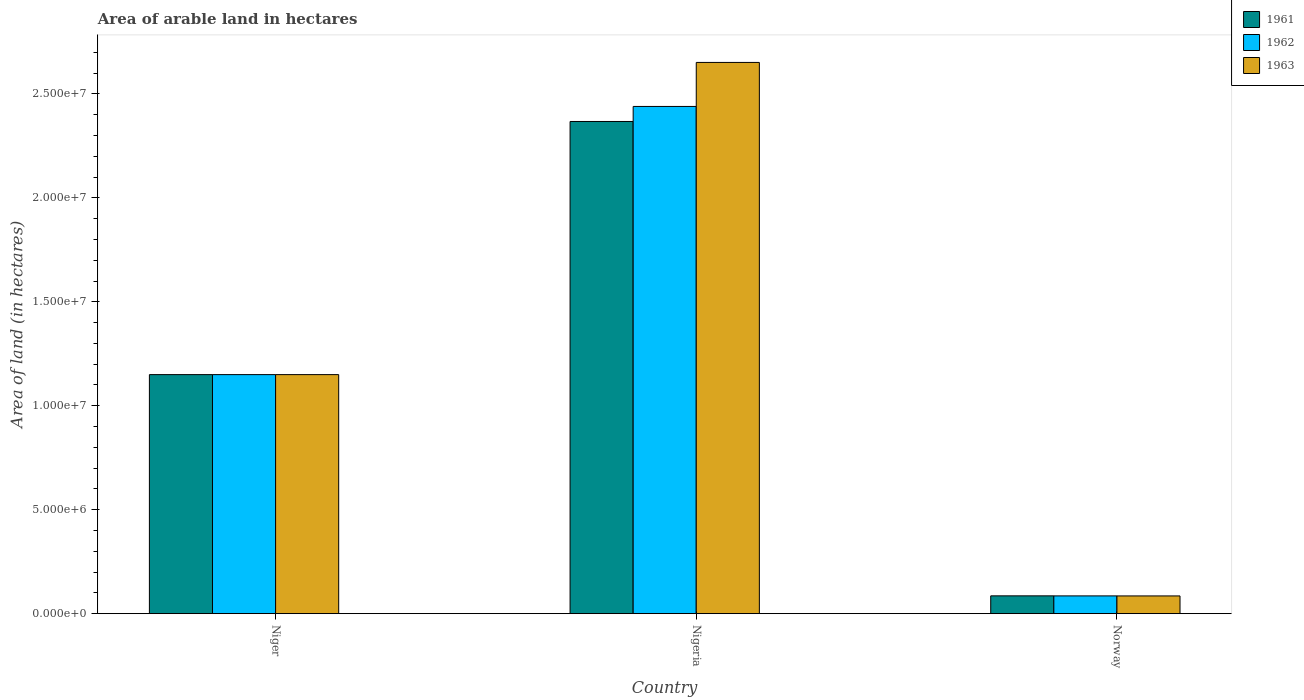How many groups of bars are there?
Give a very brief answer. 3. Are the number of bars per tick equal to the number of legend labels?
Provide a succinct answer. Yes. Are the number of bars on each tick of the X-axis equal?
Your answer should be very brief. Yes. How many bars are there on the 3rd tick from the left?
Give a very brief answer. 3. How many bars are there on the 2nd tick from the right?
Ensure brevity in your answer.  3. What is the label of the 1st group of bars from the left?
Offer a terse response. Niger. In how many cases, is the number of bars for a given country not equal to the number of legend labels?
Make the answer very short. 0. What is the total arable land in 1961 in Niger?
Your answer should be compact. 1.15e+07. Across all countries, what is the maximum total arable land in 1963?
Ensure brevity in your answer.  2.65e+07. Across all countries, what is the minimum total arable land in 1963?
Offer a very short reply. 8.52e+05. In which country was the total arable land in 1962 maximum?
Keep it short and to the point. Nigeria. In which country was the total arable land in 1962 minimum?
Ensure brevity in your answer.  Norway. What is the total total arable land in 1962 in the graph?
Provide a succinct answer. 3.68e+07. What is the difference between the total arable land in 1962 in Niger and that in Nigeria?
Provide a succinct answer. -1.29e+07. What is the difference between the total arable land in 1963 in Niger and the total arable land in 1962 in Norway?
Your answer should be compact. 1.06e+07. What is the average total arable land in 1962 per country?
Your answer should be compact. 1.23e+07. What is the difference between the total arable land of/in 1961 and total arable land of/in 1962 in Niger?
Your response must be concise. 0. What is the ratio of the total arable land in 1963 in Niger to that in Norway?
Provide a short and direct response. 13.5. Is the total arable land in 1962 in Nigeria less than that in Norway?
Your answer should be very brief. No. Is the difference between the total arable land in 1961 in Niger and Nigeria greater than the difference between the total arable land in 1962 in Niger and Nigeria?
Offer a very short reply. Yes. What is the difference between the highest and the second highest total arable land in 1962?
Ensure brevity in your answer.  2.35e+07. What is the difference between the highest and the lowest total arable land in 1961?
Provide a succinct answer. 2.28e+07. In how many countries, is the total arable land in 1962 greater than the average total arable land in 1962 taken over all countries?
Provide a succinct answer. 1. What does the 1st bar from the left in Niger represents?
Give a very brief answer. 1961. Are all the bars in the graph horizontal?
Your response must be concise. No. Where does the legend appear in the graph?
Give a very brief answer. Top right. How many legend labels are there?
Your answer should be compact. 3. How are the legend labels stacked?
Provide a short and direct response. Vertical. What is the title of the graph?
Offer a very short reply. Area of arable land in hectares. What is the label or title of the Y-axis?
Provide a succinct answer. Area of land (in hectares). What is the Area of land (in hectares) in 1961 in Niger?
Make the answer very short. 1.15e+07. What is the Area of land (in hectares) in 1962 in Niger?
Your response must be concise. 1.15e+07. What is the Area of land (in hectares) in 1963 in Niger?
Make the answer very short. 1.15e+07. What is the Area of land (in hectares) in 1961 in Nigeria?
Provide a succinct answer. 2.37e+07. What is the Area of land (in hectares) in 1962 in Nigeria?
Your answer should be very brief. 2.44e+07. What is the Area of land (in hectares) of 1963 in Nigeria?
Offer a very short reply. 2.65e+07. What is the Area of land (in hectares) of 1961 in Norway?
Keep it short and to the point. 8.56e+05. What is the Area of land (in hectares) of 1962 in Norway?
Ensure brevity in your answer.  8.54e+05. What is the Area of land (in hectares) of 1963 in Norway?
Ensure brevity in your answer.  8.52e+05. Across all countries, what is the maximum Area of land (in hectares) in 1961?
Give a very brief answer. 2.37e+07. Across all countries, what is the maximum Area of land (in hectares) in 1962?
Your response must be concise. 2.44e+07. Across all countries, what is the maximum Area of land (in hectares) in 1963?
Give a very brief answer. 2.65e+07. Across all countries, what is the minimum Area of land (in hectares) of 1961?
Provide a succinct answer. 8.56e+05. Across all countries, what is the minimum Area of land (in hectares) in 1962?
Offer a very short reply. 8.54e+05. Across all countries, what is the minimum Area of land (in hectares) of 1963?
Ensure brevity in your answer.  8.52e+05. What is the total Area of land (in hectares) in 1961 in the graph?
Provide a short and direct response. 3.60e+07. What is the total Area of land (in hectares) in 1962 in the graph?
Your response must be concise. 3.68e+07. What is the total Area of land (in hectares) of 1963 in the graph?
Your answer should be very brief. 3.89e+07. What is the difference between the Area of land (in hectares) of 1961 in Niger and that in Nigeria?
Offer a terse response. -1.22e+07. What is the difference between the Area of land (in hectares) in 1962 in Niger and that in Nigeria?
Offer a terse response. -1.29e+07. What is the difference between the Area of land (in hectares) in 1963 in Niger and that in Nigeria?
Your answer should be very brief. -1.50e+07. What is the difference between the Area of land (in hectares) in 1961 in Niger and that in Norway?
Offer a terse response. 1.06e+07. What is the difference between the Area of land (in hectares) of 1962 in Niger and that in Norway?
Ensure brevity in your answer.  1.06e+07. What is the difference between the Area of land (in hectares) in 1963 in Niger and that in Norway?
Give a very brief answer. 1.06e+07. What is the difference between the Area of land (in hectares) in 1961 in Nigeria and that in Norway?
Your response must be concise. 2.28e+07. What is the difference between the Area of land (in hectares) of 1962 in Nigeria and that in Norway?
Give a very brief answer. 2.35e+07. What is the difference between the Area of land (in hectares) of 1963 in Nigeria and that in Norway?
Provide a succinct answer. 2.57e+07. What is the difference between the Area of land (in hectares) of 1961 in Niger and the Area of land (in hectares) of 1962 in Nigeria?
Keep it short and to the point. -1.29e+07. What is the difference between the Area of land (in hectares) in 1961 in Niger and the Area of land (in hectares) in 1963 in Nigeria?
Your response must be concise. -1.50e+07. What is the difference between the Area of land (in hectares) of 1962 in Niger and the Area of land (in hectares) of 1963 in Nigeria?
Give a very brief answer. -1.50e+07. What is the difference between the Area of land (in hectares) in 1961 in Niger and the Area of land (in hectares) in 1962 in Norway?
Provide a short and direct response. 1.06e+07. What is the difference between the Area of land (in hectares) of 1961 in Niger and the Area of land (in hectares) of 1963 in Norway?
Make the answer very short. 1.06e+07. What is the difference between the Area of land (in hectares) of 1962 in Niger and the Area of land (in hectares) of 1963 in Norway?
Ensure brevity in your answer.  1.06e+07. What is the difference between the Area of land (in hectares) in 1961 in Nigeria and the Area of land (in hectares) in 1962 in Norway?
Provide a short and direct response. 2.28e+07. What is the difference between the Area of land (in hectares) of 1961 in Nigeria and the Area of land (in hectares) of 1963 in Norway?
Your answer should be compact. 2.28e+07. What is the difference between the Area of land (in hectares) of 1962 in Nigeria and the Area of land (in hectares) of 1963 in Norway?
Your response must be concise. 2.35e+07. What is the average Area of land (in hectares) of 1961 per country?
Provide a succinct answer. 1.20e+07. What is the average Area of land (in hectares) of 1962 per country?
Keep it short and to the point. 1.23e+07. What is the average Area of land (in hectares) of 1963 per country?
Make the answer very short. 1.30e+07. What is the difference between the Area of land (in hectares) in 1961 and Area of land (in hectares) in 1963 in Niger?
Provide a short and direct response. 0. What is the difference between the Area of land (in hectares) in 1961 and Area of land (in hectares) in 1962 in Nigeria?
Give a very brief answer. -7.23e+05. What is the difference between the Area of land (in hectares) in 1961 and Area of land (in hectares) in 1963 in Nigeria?
Offer a very short reply. -2.84e+06. What is the difference between the Area of land (in hectares) in 1962 and Area of land (in hectares) in 1963 in Nigeria?
Your response must be concise. -2.12e+06. What is the difference between the Area of land (in hectares) in 1961 and Area of land (in hectares) in 1962 in Norway?
Make the answer very short. 2000. What is the difference between the Area of land (in hectares) in 1961 and Area of land (in hectares) in 1963 in Norway?
Ensure brevity in your answer.  4000. What is the ratio of the Area of land (in hectares) in 1961 in Niger to that in Nigeria?
Offer a terse response. 0.49. What is the ratio of the Area of land (in hectares) of 1962 in Niger to that in Nigeria?
Keep it short and to the point. 0.47. What is the ratio of the Area of land (in hectares) of 1963 in Niger to that in Nigeria?
Offer a very short reply. 0.43. What is the ratio of the Area of land (in hectares) of 1961 in Niger to that in Norway?
Provide a succinct answer. 13.43. What is the ratio of the Area of land (in hectares) of 1962 in Niger to that in Norway?
Your answer should be compact. 13.46. What is the ratio of the Area of land (in hectares) in 1963 in Niger to that in Norway?
Give a very brief answer. 13.5. What is the ratio of the Area of land (in hectares) of 1961 in Nigeria to that in Norway?
Provide a succinct answer. 27.66. What is the ratio of the Area of land (in hectares) of 1962 in Nigeria to that in Norway?
Keep it short and to the point. 28.57. What is the ratio of the Area of land (in hectares) of 1963 in Nigeria to that in Norway?
Provide a succinct answer. 31.12. What is the difference between the highest and the second highest Area of land (in hectares) of 1961?
Your answer should be compact. 1.22e+07. What is the difference between the highest and the second highest Area of land (in hectares) in 1962?
Offer a very short reply. 1.29e+07. What is the difference between the highest and the second highest Area of land (in hectares) in 1963?
Your answer should be compact. 1.50e+07. What is the difference between the highest and the lowest Area of land (in hectares) in 1961?
Ensure brevity in your answer.  2.28e+07. What is the difference between the highest and the lowest Area of land (in hectares) in 1962?
Provide a short and direct response. 2.35e+07. What is the difference between the highest and the lowest Area of land (in hectares) of 1963?
Ensure brevity in your answer.  2.57e+07. 